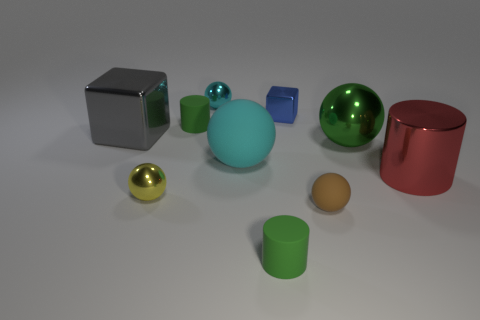Subtract all green balls. How many balls are left? 4 Subtract 1 spheres. How many spheres are left? 4 Subtract all green spheres. How many spheres are left? 4 Subtract all red balls. Subtract all gray cylinders. How many balls are left? 5 Subtract all blocks. How many objects are left? 8 Add 2 tiny yellow cubes. How many tiny yellow cubes exist? 2 Subtract 0 blue spheres. How many objects are left? 10 Subtract all tiny green cylinders. Subtract all large cyan rubber objects. How many objects are left? 7 Add 1 shiny cylinders. How many shiny cylinders are left? 2 